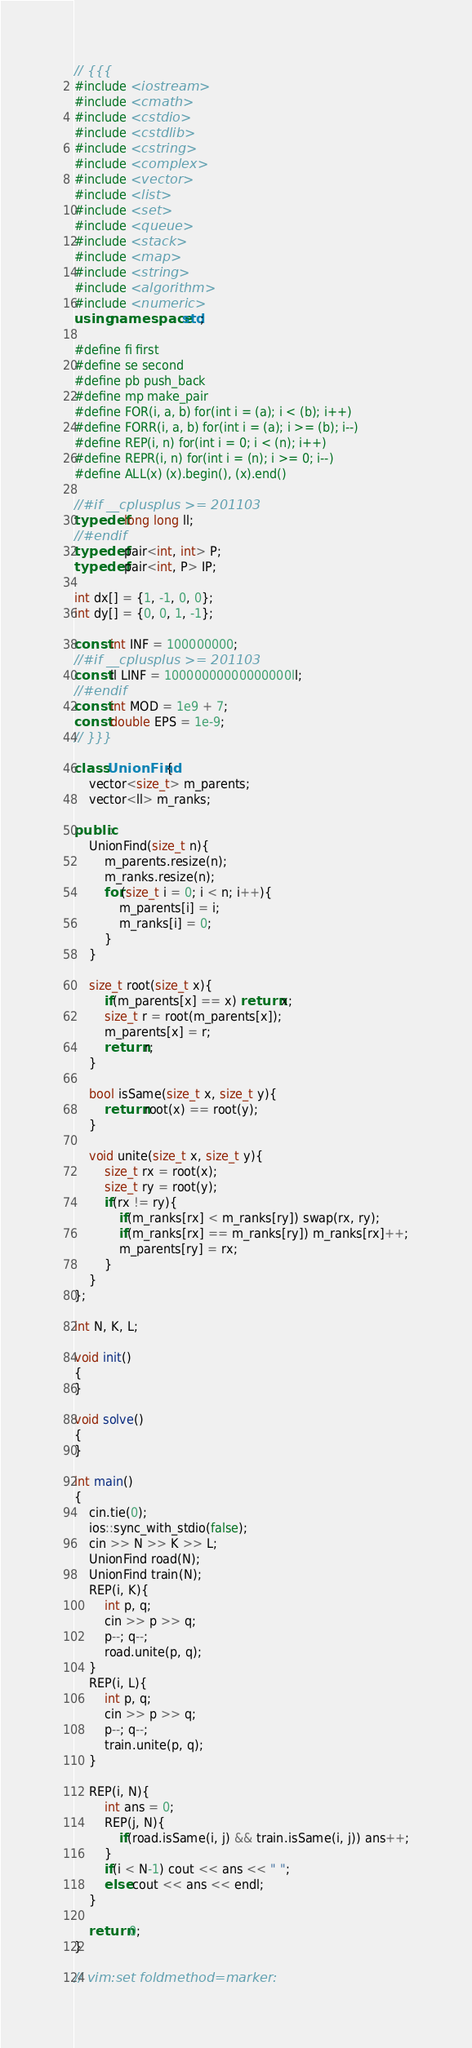<code> <loc_0><loc_0><loc_500><loc_500><_C++_>// {{{
#include <iostream>
#include <cmath>
#include <cstdio>
#include <cstdlib>
#include <cstring>
#include <complex>
#include <vector>
#include <list>
#include <set>
#include <queue>
#include <stack>
#include <map>
#include <string>
#include <algorithm>
#include <numeric>
using namespace std;

#define fi first
#define se second
#define pb push_back
#define mp make_pair
#define FOR(i, a, b) for(int i = (a); i < (b); i++)
#define FORR(i, a, b) for(int i = (a); i >= (b); i--)
#define REP(i, n) for(int i = 0; i < (n); i++)
#define REPR(i, n) for(int i = (n); i >= 0; i--)
#define ALL(x) (x).begin(), (x).end()

//#if __cplusplus >= 201103
typedef long long ll;
//#endif
typedef pair<int, int> P;
typedef pair<int, P> IP;

int dx[] = {1, -1, 0, 0};
int dy[] = {0, 0, 1, -1};

const int INF = 100000000;
//#if __cplusplus >= 201103
const ll LINF = 10000000000000000ll;
//#endif
const int MOD = 1e9 + 7;
const double EPS = 1e-9;
// }}}

class UnionFind{
    vector<size_t> m_parents;
    vector<ll> m_ranks;

public:
    UnionFind(size_t n){
        m_parents.resize(n);
        m_ranks.resize(n);
        for(size_t i = 0; i < n; i++){
            m_parents[i] = i;
            m_ranks[i] = 0;
        }
    }

    size_t root(size_t x){
        if(m_parents[x] == x) return x;
        size_t r = root(m_parents[x]);
        m_parents[x] = r;
        return r;
    }

    bool isSame(size_t x, size_t y){
        return root(x) == root(y);
    }

    void unite(size_t x, size_t y){
        size_t rx = root(x);
        size_t ry = root(y);
        if(rx != ry){
            if(m_ranks[rx] < m_ranks[ry]) swap(rx, ry);
            if(m_ranks[rx] == m_ranks[ry]) m_ranks[rx]++;
            m_parents[ry] = rx;
        }
    }
};

int N, K, L;

void init()
{
}

void solve()
{
}

int main()
{
    cin.tie(0);
    ios::sync_with_stdio(false);
    cin >> N >> K >> L;
    UnionFind road(N);
    UnionFind train(N);
    REP(i, K){
        int p, q;
        cin >> p >> q;
        p--; q--;
        road.unite(p, q);
    }
    REP(i, L){
        int p, q;
        cin >> p >> q;
        p--; q--;
        train.unite(p, q);
    }

    REP(i, N){
        int ans = 0;
        REP(j, N){
            if(road.isSame(i, j) && train.isSame(i, j)) ans++;
        }
        if(i < N-1) cout << ans << " ";
        else cout << ans << endl;
    }

    return 0;
}

// vim:set foldmethod=marker:
</code> 